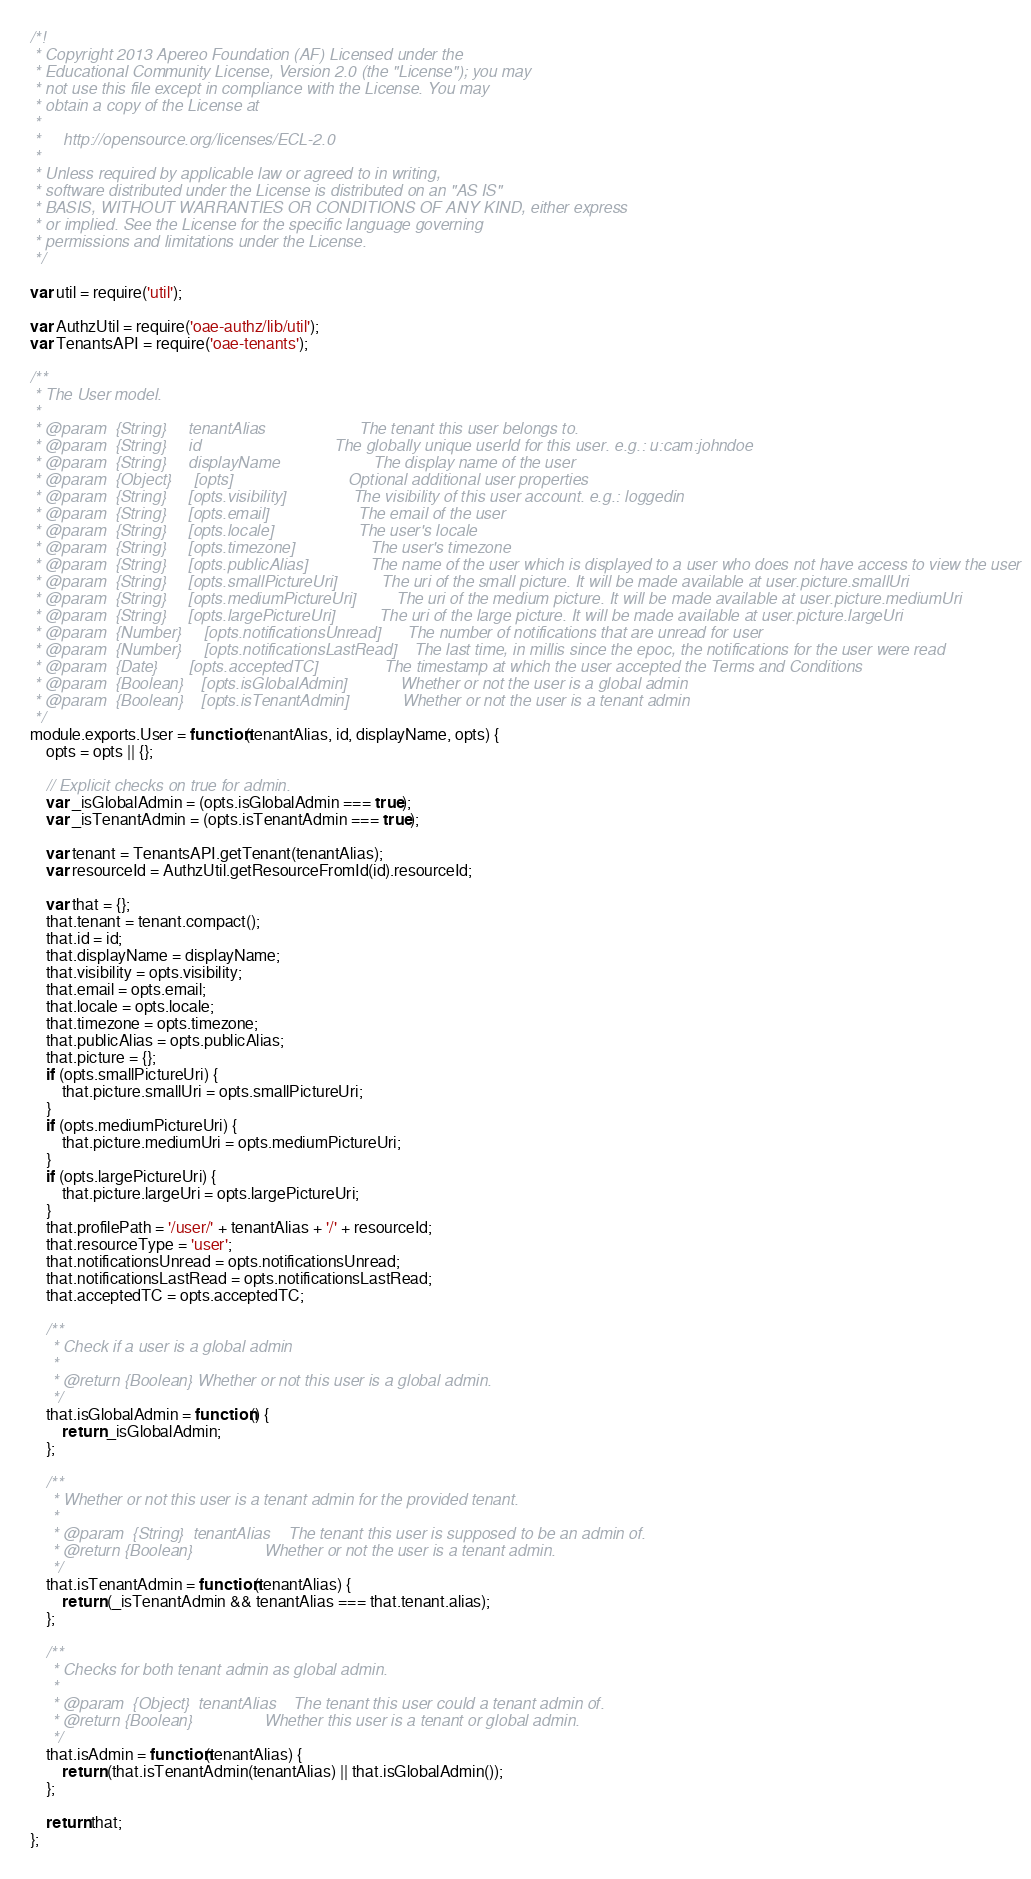Convert code to text. <code><loc_0><loc_0><loc_500><loc_500><_JavaScript_>/*!
 * Copyright 2013 Apereo Foundation (AF) Licensed under the
 * Educational Community License, Version 2.0 (the "License"); you may
 * not use this file except in compliance with the License. You may
 * obtain a copy of the License at
 *
 *     http://opensource.org/licenses/ECL-2.0
 *
 * Unless required by applicable law or agreed to in writing,
 * software distributed under the License is distributed on an "AS IS"
 * BASIS, WITHOUT WARRANTIES OR CONDITIONS OF ANY KIND, either express
 * or implied. See the License for the specific language governing
 * permissions and limitations under the License.
 */

var util = require('util');

var AuthzUtil = require('oae-authz/lib/util');
var TenantsAPI = require('oae-tenants');

/**
 * The User model.
 *
 * @param  {String}     tenantAlias                     The tenant this user belongs to.
 * @param  {String}     id                              The globally unique userId for this user. e.g.: u:cam:johndoe
 * @param  {String}     displayName                     The display name of the user
 * @param  {Object}     [opts]                          Optional additional user properties
 * @param  {String}     [opts.visibility]               The visibility of this user account. e.g.: loggedin
 * @param  {String}     [opts.email]                    The email of the user
 * @param  {String}     [opts.locale]                   The user's locale
 * @param  {String}     [opts.timezone]                 The user's timezone
 * @param  {String}     [opts.publicAlias]              The name of the user which is displayed to a user who does not have access to view the user
 * @param  {String}     [opts.smallPictureUri]          The uri of the small picture. It will be made available at user.picture.smallUri
 * @param  {String}     [opts.mediumPictureUri]         The uri of the medium picture. It will be made available at user.picture.mediumUri
 * @param  {String}     [opts.largePictureUri]          The uri of the large picture. It will be made available at user.picture.largeUri
 * @param  {Number}     [opts.notificationsUnread]      The number of notifications that are unread for user
 * @param  {Number}     [opts.notificationsLastRead]    The last time, in millis since the epoc, the notifications for the user were read
 * @param  {Date}       [opts.acceptedTC]               The timestamp at which the user accepted the Terms and Conditions
 * @param  {Boolean}    [opts.isGlobalAdmin]            Whether or not the user is a global admin
 * @param  {Boolean}    [opts.isTenantAdmin]            Whether or not the user is a tenant admin
 */
module.exports.User = function(tenantAlias, id, displayName, opts) {
    opts = opts || {};

    // Explicit checks on true for admin.
    var _isGlobalAdmin = (opts.isGlobalAdmin === true);
    var _isTenantAdmin = (opts.isTenantAdmin === true);

    var tenant = TenantsAPI.getTenant(tenantAlias);
    var resourceId = AuthzUtil.getResourceFromId(id).resourceId;

    var that = {};
    that.tenant = tenant.compact();
    that.id = id;
    that.displayName = displayName;
    that.visibility = opts.visibility;
    that.email = opts.email;
    that.locale = opts.locale;
    that.timezone = opts.timezone;
    that.publicAlias = opts.publicAlias;
    that.picture = {};
    if (opts.smallPictureUri) {
        that.picture.smallUri = opts.smallPictureUri;
    }
    if (opts.mediumPictureUri) {
        that.picture.mediumUri = opts.mediumPictureUri;
    }
    if (opts.largePictureUri) {
        that.picture.largeUri = opts.largePictureUri;
    }
    that.profilePath = '/user/' + tenantAlias + '/' + resourceId;
    that.resourceType = 'user';
    that.notificationsUnread = opts.notificationsUnread;
    that.notificationsLastRead = opts.notificationsLastRead;
    that.acceptedTC = opts.acceptedTC;

    /**
     * Check if a user is a global admin
     *
     * @return {Boolean} Whether or not this user is a global admin.
     */
    that.isGlobalAdmin = function() {
        return _isGlobalAdmin;
    };

    /**
     * Whether or not this user is a tenant admin for the provided tenant.
     *
     * @param  {String}  tenantAlias    The tenant this user is supposed to be an admin of.
     * @return {Boolean}                Whether or not the user is a tenant admin.
     */
    that.isTenantAdmin = function(tenantAlias) {
        return (_isTenantAdmin && tenantAlias === that.tenant.alias);
    };

    /**
     * Checks for both tenant admin as global admin.
     *
     * @param  {Object}  tenantAlias    The tenant this user could a tenant admin of.
     * @return {Boolean}                Whether this user is a tenant or global admin.
     */
    that.isAdmin = function(tenantAlias) {
        return (that.isTenantAdmin(tenantAlias) || that.isGlobalAdmin());
    };

    return that;
};
</code> 